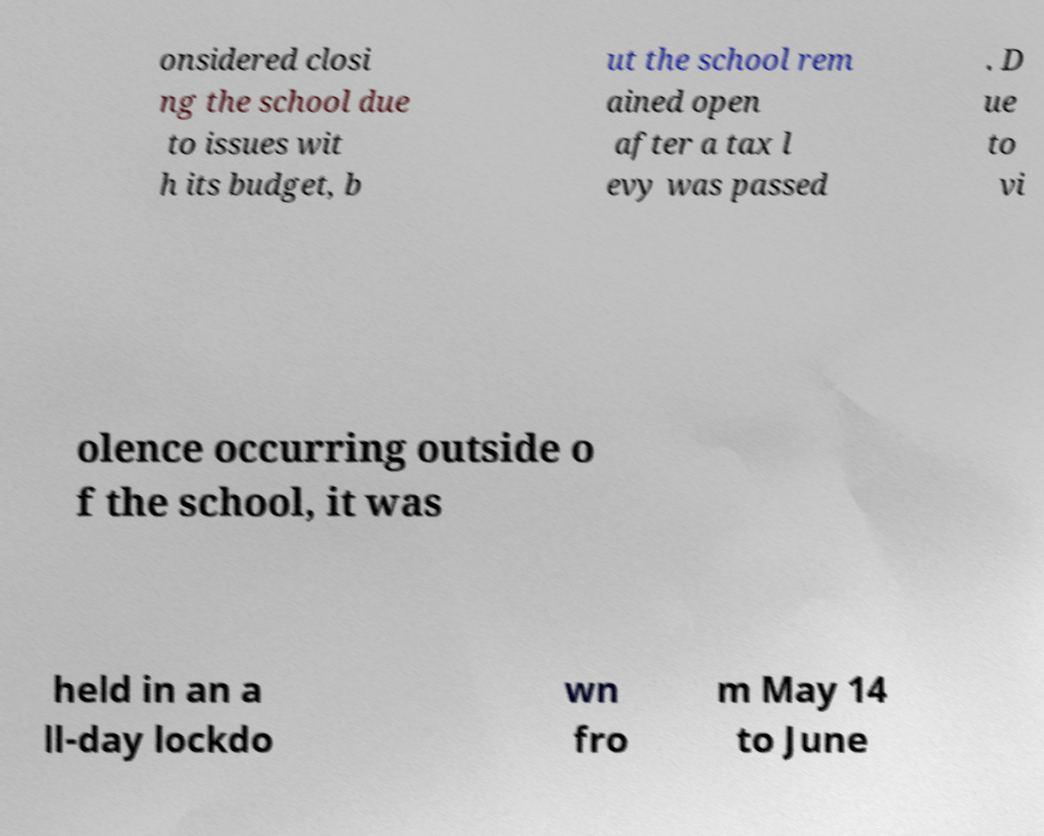Can you read and provide the text displayed in the image?This photo seems to have some interesting text. Can you extract and type it out for me? onsidered closi ng the school due to issues wit h its budget, b ut the school rem ained open after a tax l evy was passed . D ue to vi olence occurring outside o f the school, it was held in an a ll-day lockdo wn fro m May 14 to June 